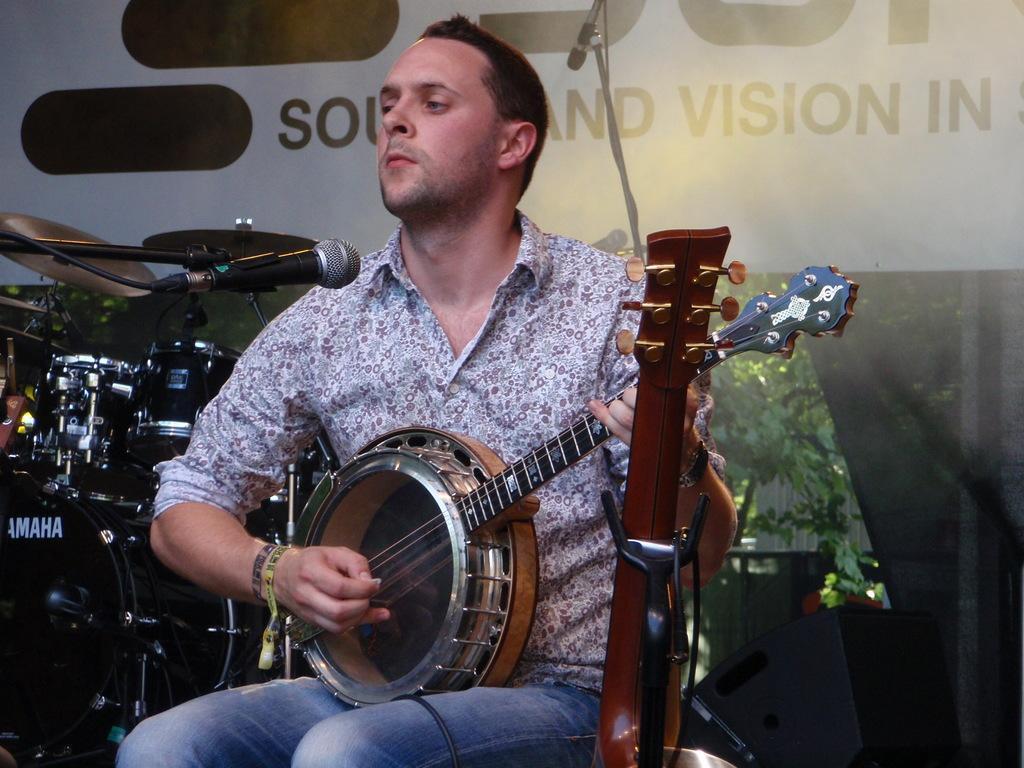How would you summarize this image in a sentence or two? A man is sitting on the chair and playing a musical instrument. He wear a shirt and jeans. 